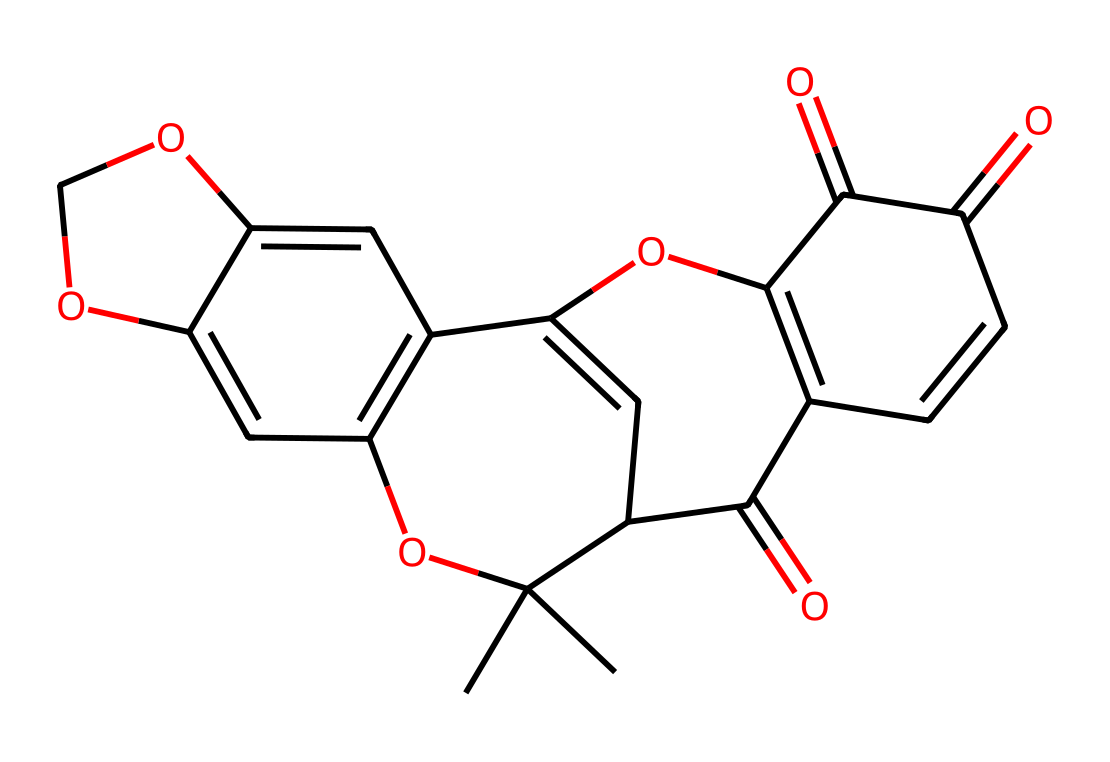what is the molecular formula of rotenone? To determine the molecular formula, we analyze the provided SMILES representation. Count the number of carbon (C), hydrogen (H), and oxygen (O) atoms in the structure. The total comes to 27 carbon atoms, 28 hydrogen atoms, and 8 oxygen atoms, leading to the molecular formula C27H28O8.
Answer: C27H28O8 how many stereocenters are present in the structure of rotenone? A stereocenter is typically a carbon atom bonded to four different substituents. Examining the structure reveals that there are three such carbon atoms that meet this criterion, indicating the presence of three stereocenters in the molecule.
Answer: 3 what functional groups are identifiable in rotenone? Identifying functional groups involves looking for specific arrangements of atoms. In the structure of rotenone, we can see the presence of a ketone (C=O), an alcohol (–OH), and an ether (–O–) group based on the arrangement of the atoms in the SMILES.
Answer: ketone, alcohol, ether what is the role of the methoxy group in rotenone? The methoxy group (–OCH3) can influence the solubility and the biological activity of the pesticide. In the context of rotenone, it helps in the insecticidal effect by altering its interaction with target organisms, enhancing its efficacy.
Answer: insecticidal activity is rotenone a broad-spectrum insecticide? Broad-spectrum insecticides effectively target a wide variety of pests. Based on its mechanism of action, which interrupts cellular respiration in many insects, rotenone is classified as a broad-spectrum insecticide.
Answer: yes 